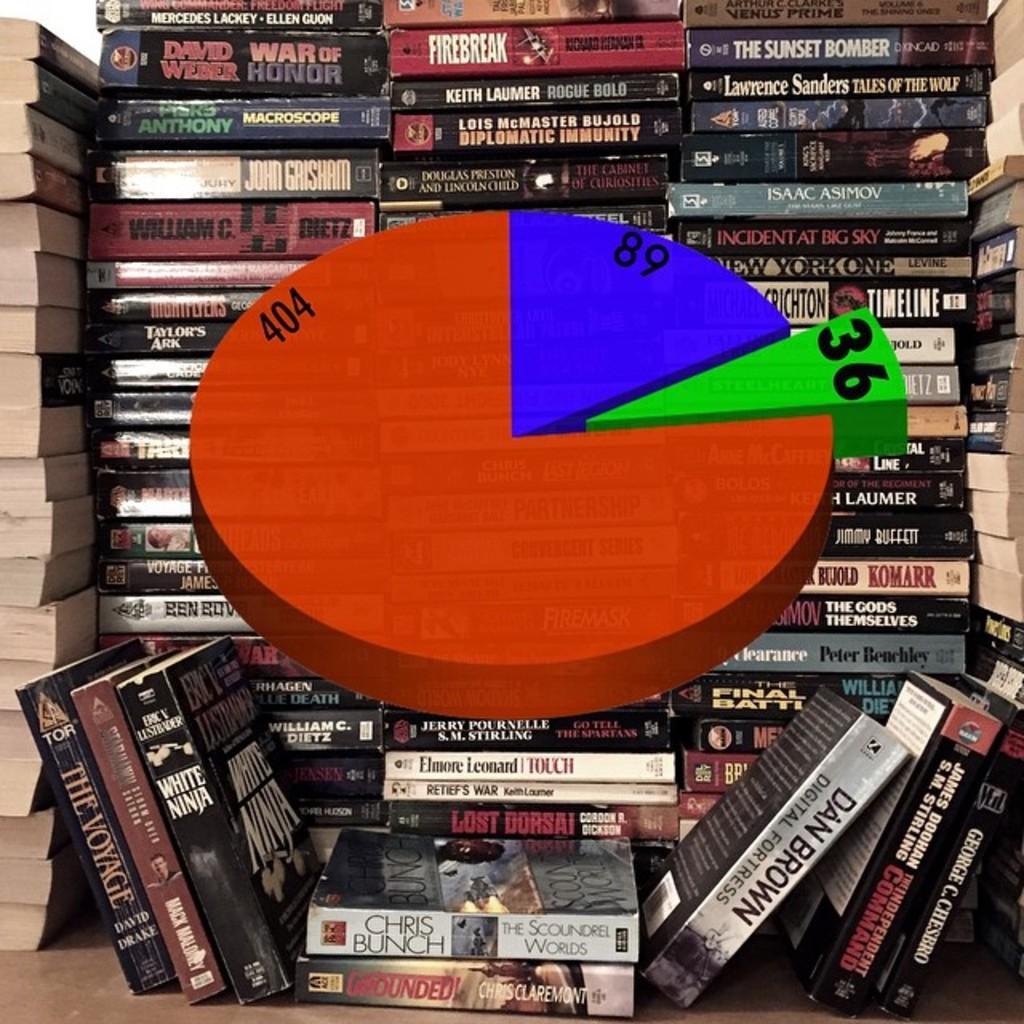Can you describe this image briefly? In the center of the image we can see a pie diagram. In the background there are books arranged in a rows. 